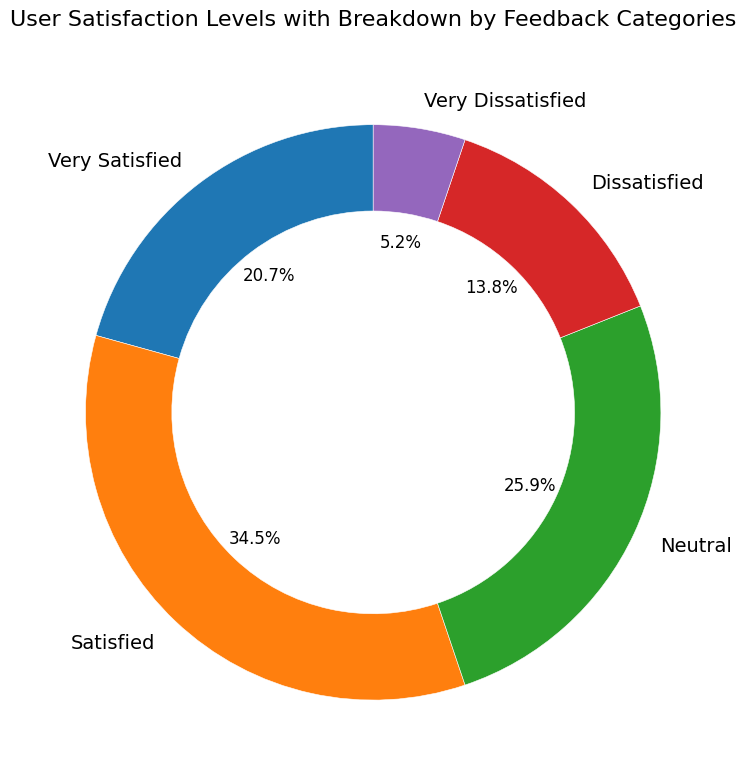What percentage of users were either Dissatisfied or Very Dissatisfied? Summing up the percentages for Dissatisfied (80 counts) and Very Dissatisfied (30 counts) gives a total count of 110. Adding up all feedback categories gives a total count of 580. The percentage is (110/580) * 100 = 18.97%, which rounds to approximately 19.0%
Answer: 19.0% Which category has the highest number of users? The category with the highest count is "Satisfied" with 200 users, as seen from the chart.
Answer: Satisfied How does the number of Very Dissatisfied users compare to Dissatisfied users? There are 30 Very Dissatisfied users and 80 Dissatisfied users. The ratio of Very Dissatisfied to Dissatisfied is 30:80, which simplifies to 3:8, indicating that there are more than twice as many Dissatisfied users as Very Dissatisfied users.
Answer: Dissatisfied users are more Which category has the smallest visual representation in the chart? The category "Very Dissatisfied" has the smallest slice in the ring chart, indicating the lowest count of 30 users.
Answer: Very Dissatisfied What is the difference in user counts between Satisfied and Dissatisfied categories? Satisfied users count is 200 and Dissatisfied users count is 80. The difference is 200 - 80 = 120.
Answer: 120 What is the combined percentage of users who are not Neutral? Combining the percentages of Very Satisfied (120 counts), Satisfied (200 counts), Dissatisfied (80 counts), and Very Dissatisfied (30 counts): (120 + 200 + 80 + 30) / 580 = 430 / 580 = 74.1%.
Answer: 74.1% Between Satisfied and Very Satisfied users, how much greater is the Satisfied user count? Satisfied users are 200 and Very Satisfied users are 120. The difference is 200 - 120 = 80.
Answer: 80 What percentage of the total do Neutral users constitute? Neutral users are 150 out of the total of 580, so (150/580) * 100 = 25.9%.
Answer: 25.9% Are there more users who are Neutral or Dissatisfied, and by how many? Neutral users are 150, whereas Dissatisfied users are 80. The difference is 150 - 80 = 70 more Neutral users.
Answer: 70 more Neutral users What is the second least frequent category in the chart? The second least frequent category after "Very Dissatisfied" (30) is "Dissatisfied" with 80 counts.
Answer: Dissatisfied 